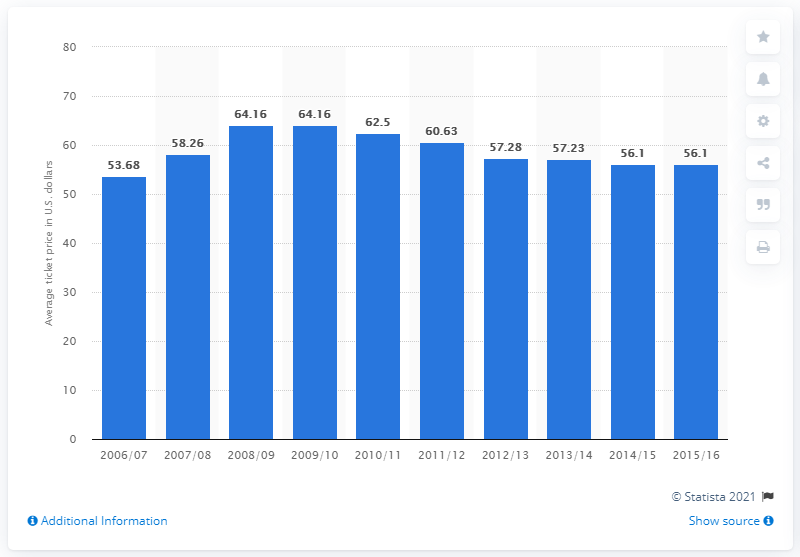List a handful of essential elements in this visual. The average ticket price for the 2006/07 season was 53.68. 